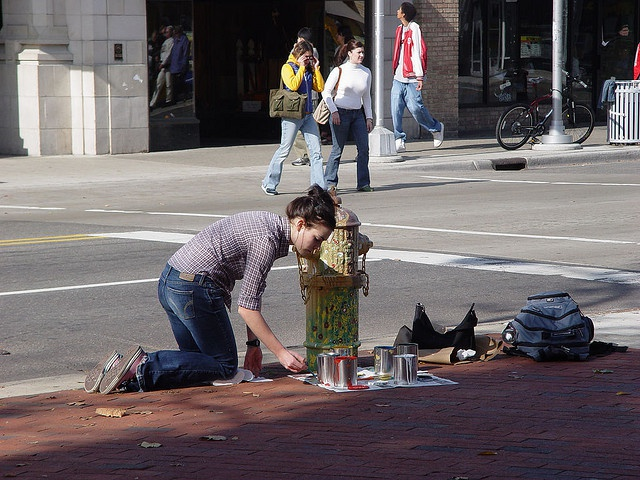Describe the objects in this image and their specific colors. I can see people in black, darkgray, gray, and lavender tones, fire hydrant in black, darkgreen, gray, and maroon tones, backpack in black, gray, navy, and darkblue tones, people in black, white, darkgray, and navy tones, and people in black, lightgray, gray, and darkgray tones in this image. 